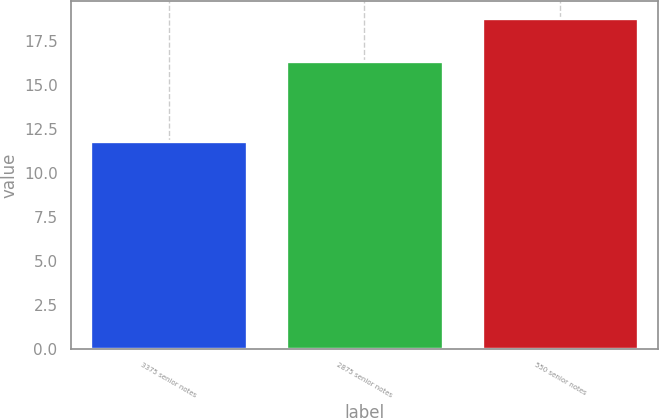<chart> <loc_0><loc_0><loc_500><loc_500><bar_chart><fcel>3375 senior notes<fcel>2875 senior notes<fcel>550 senior notes<nl><fcel>11.83<fcel>16.35<fcel>18.8<nl></chart> 